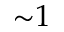<formula> <loc_0><loc_0><loc_500><loc_500>{ \sim } 1</formula> 